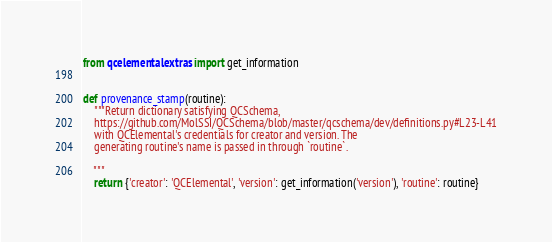Convert code to text. <code><loc_0><loc_0><loc_500><loc_500><_Python_>from qcelemental.extras import get_information


def provenance_stamp(routine):
    """Return dictionary satisfying QCSchema,
    https://github.com/MolSSI/QCSchema/blob/master/qcschema/dev/definitions.py#L23-L41
    with QCElemental's credentials for creator and version. The
    generating routine's name is passed in through `routine`.

    """
    return {'creator': 'QCElemental', 'version': get_information('version'), 'routine': routine}
</code> 